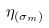Convert formula to latex. <formula><loc_0><loc_0><loc_500><loc_500>\eta _ { ( \sigma _ { m } ) }</formula> 